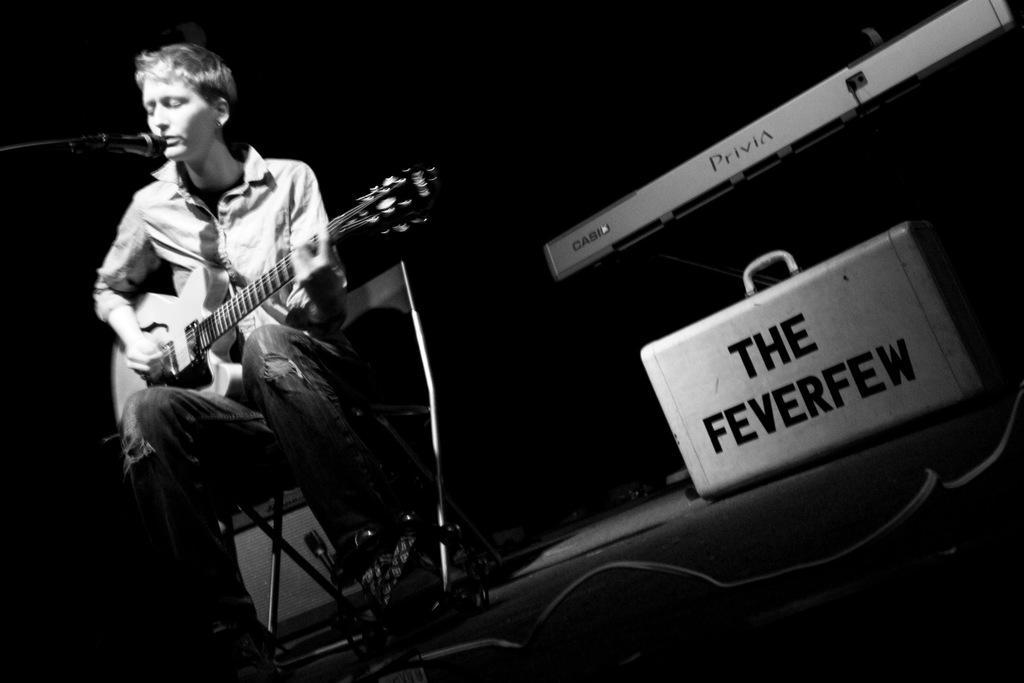Describe this image in one or two sentences. In this picture we can see man sitting on chair holding guitar in his hand and playing it and singing on mic and beside to him we can see suitcase, piano and it is dark. 